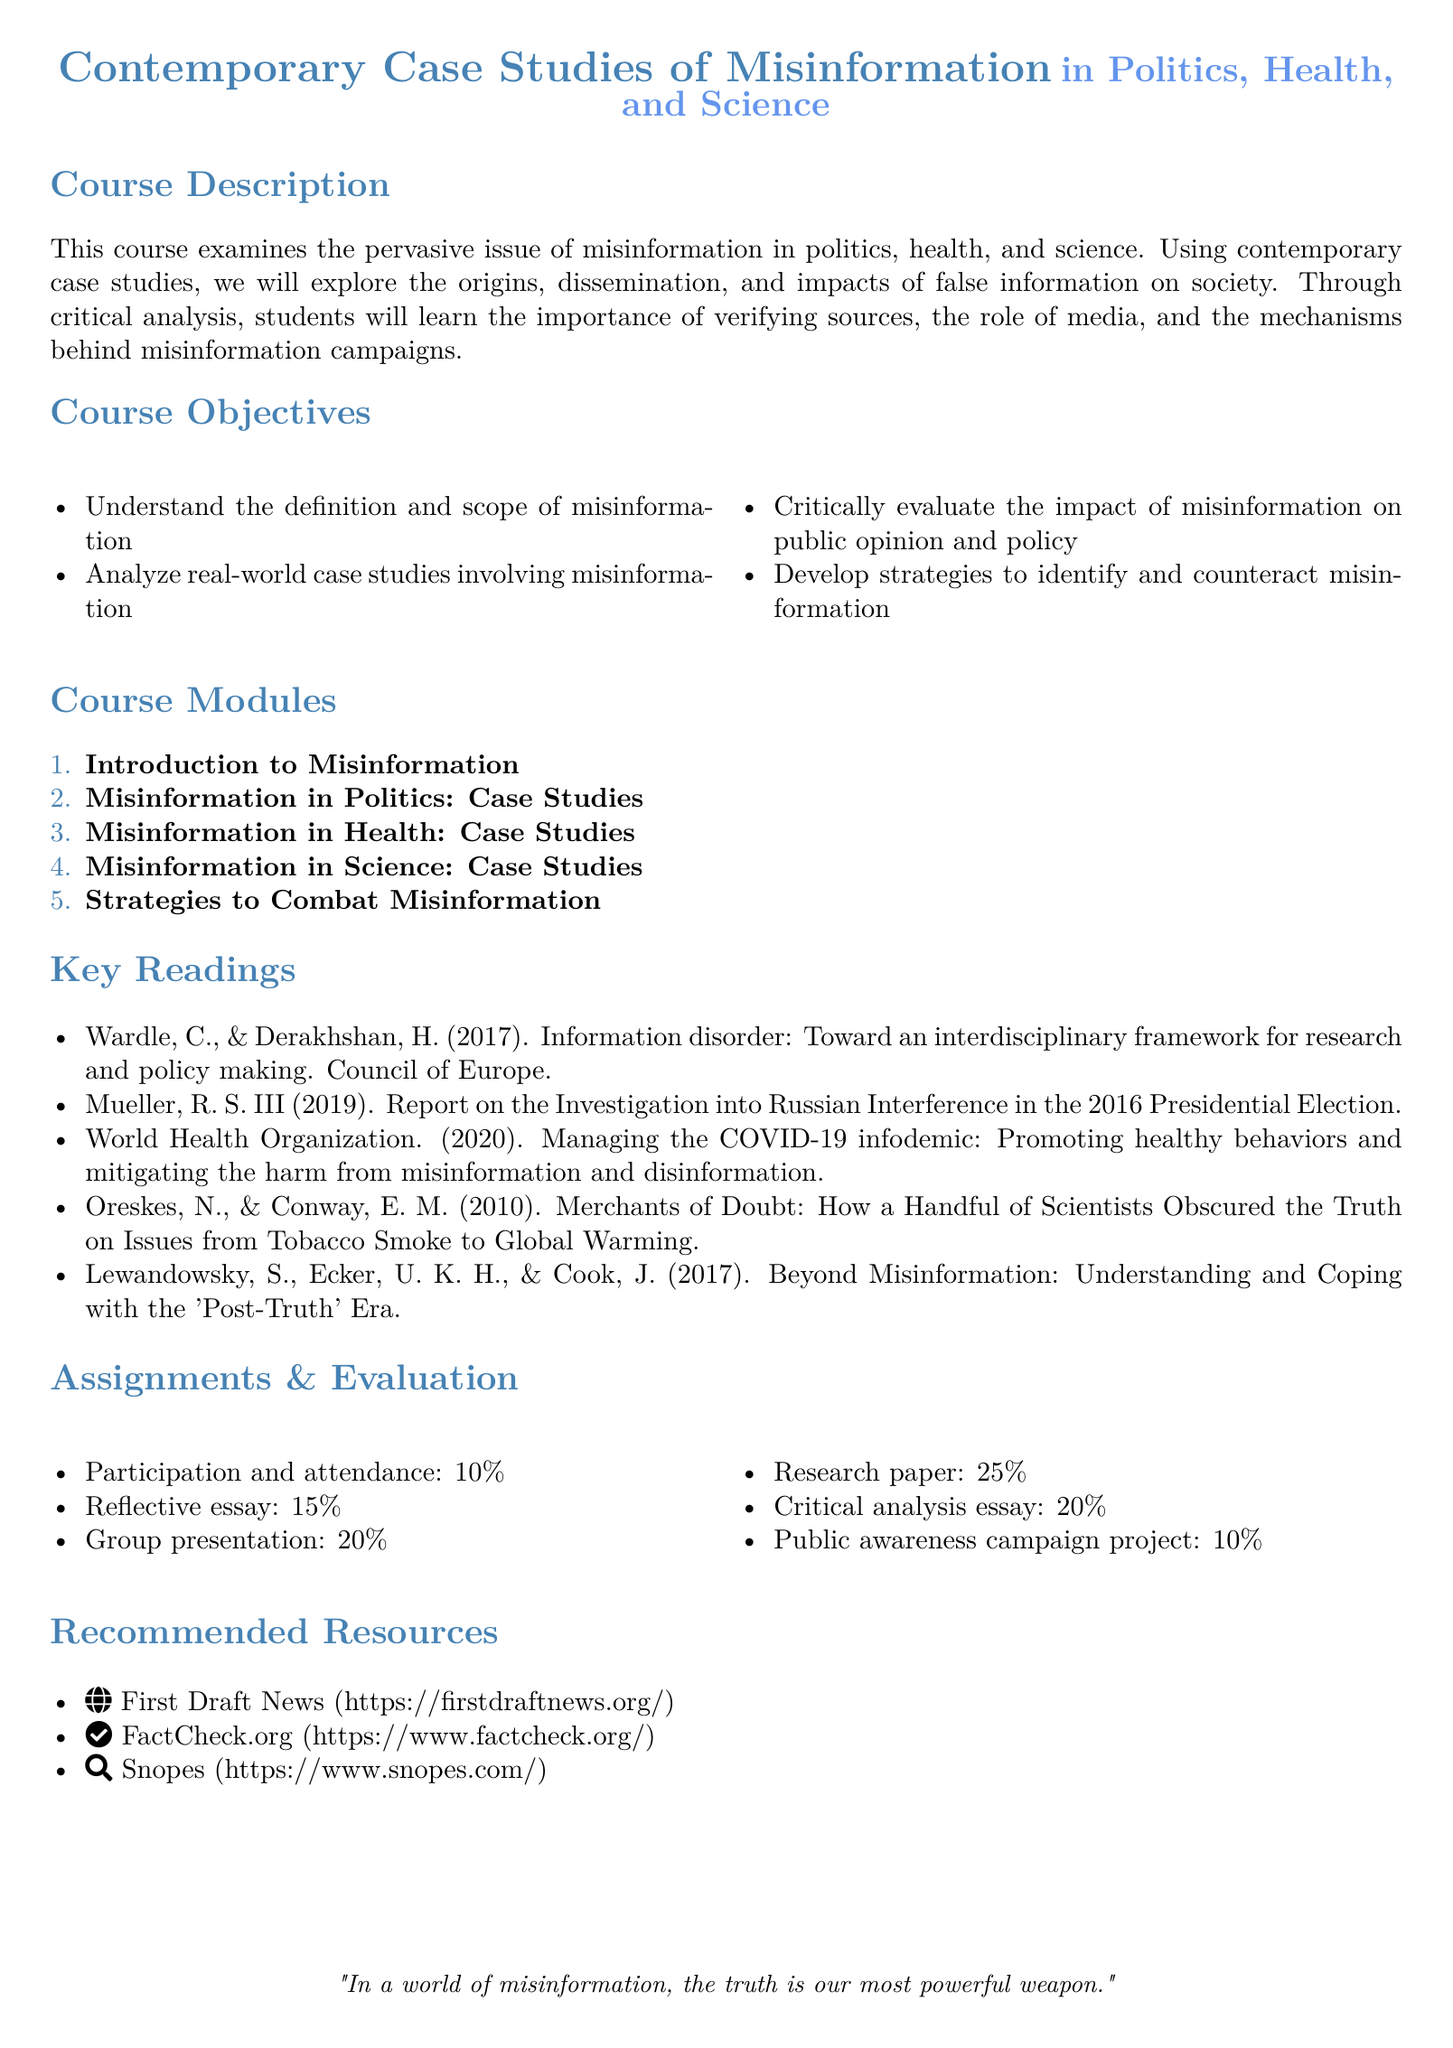What is the course title? The course title is specified at the top of the document, reflecting its focus on misinformation.
Answer: Contemporary Case Studies of Misinformation What percentage of the evaluation is based on participation and attendance? The document outlines the evaluation criteria and their respective weightings, specifically mentioning participation and attendance.
Answer: 10% Which case study category is NOT mentioned in the course modules? The course modules provide a list of topics covered but do not include a specific category related to misinformation.
Answer: N/A Who authored the report on Russian interference in the 2016 presidential election? The key readings section lists significant publications and the report is attributed to a specific individual.
Answer: Mueller, R. S. III What is the weight of the research paper in the overall evaluation? The syllabus lists separate components with their respective contributions to the final evaluation, indicating the research paper's significance.
Answer: 25% How many course modules are listed? The course modules section numerically enumerates the topics covered throughout the course.
Answer: 5 What is the maximum percentage for the reflective essay? The assignments and evaluation section allocates specific percentages to various assignments, including the reflective essay.
Answer: 15% What is the relevance of First Draft News in the recommended resources? The recommended resources provide sources that help in verifying information, which is central to combating misinformation.
Answer: Fact-checking resources 